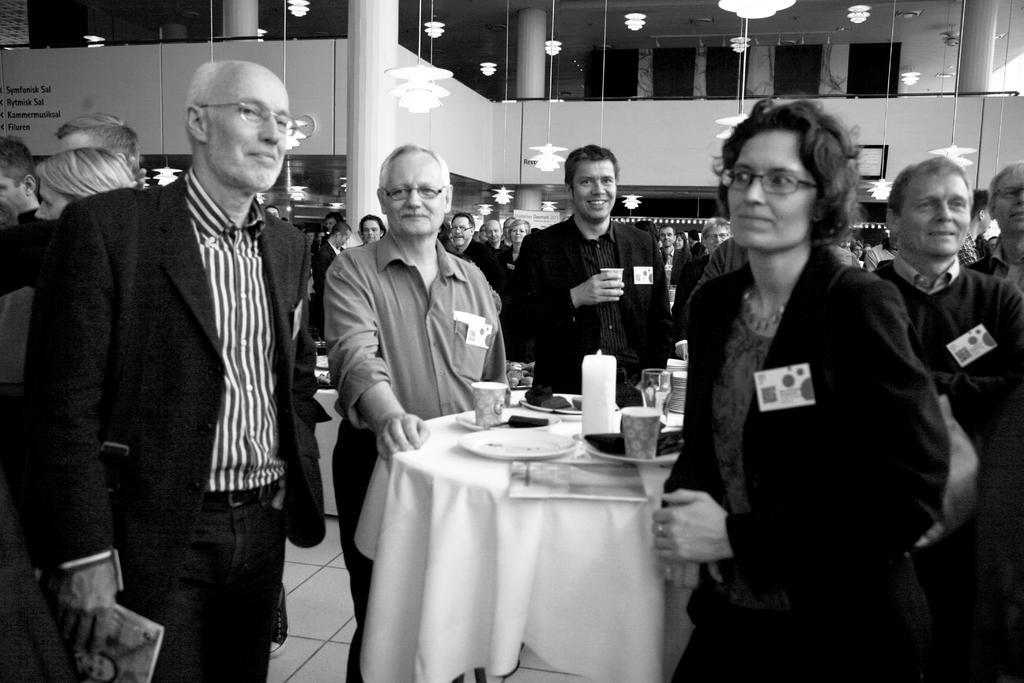Can you describe this image briefly? In this image there are who are standing around a round table. On the table there is plate,paper cup,food,glass. The woman to the right side is wearing a glass. The man to the left side is holding a book. There are four people around a round table. At the background there is a pillar,wall and a curtain. At the top there is chandelier. 